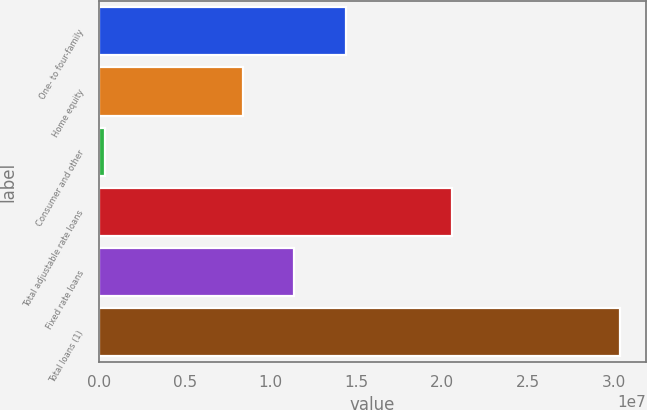Convert chart. <chart><loc_0><loc_0><loc_500><loc_500><bar_chart><fcel>One- to four-family<fcel>Home equity<fcel>Consumer and other<fcel>Total adjustable rate loans<fcel>Fixed rate loans<fcel>Total loans (1)<nl><fcel>1.43616e+07<fcel>8.36786e+06<fcel>363482<fcel>2.05846e+07<fcel>1.13647e+07<fcel>3.0332e+07<nl></chart> 